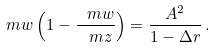<formula> <loc_0><loc_0><loc_500><loc_500>\ m w \left ( 1 - \frac { \ m w } { \ m z } \right ) & = \frac { A ^ { 2 } } { 1 - \Delta r } \, .</formula> 